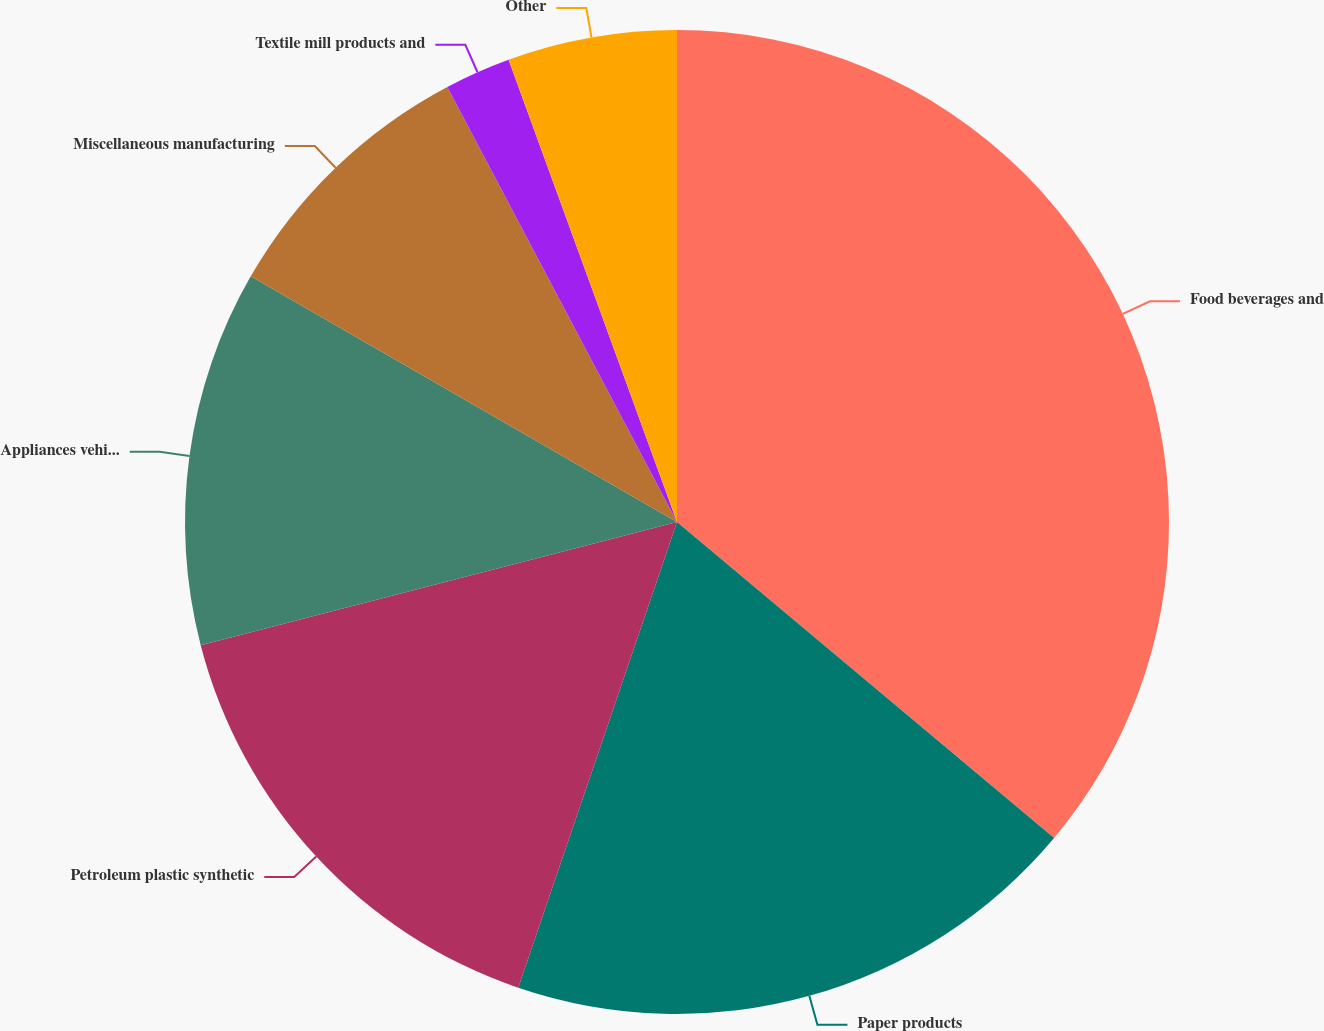Convert chart. <chart><loc_0><loc_0><loc_500><loc_500><pie_chart><fcel>Food beverages and<fcel>Paper products<fcel>Petroleum plastic synthetic<fcel>Appliances vehicles and metal<fcel>Miscellaneous manufacturing<fcel>Textile mill products and<fcel>Other<nl><fcel>36.1%<fcel>19.13%<fcel>15.74%<fcel>12.35%<fcel>8.95%<fcel>2.17%<fcel>5.56%<nl></chart> 